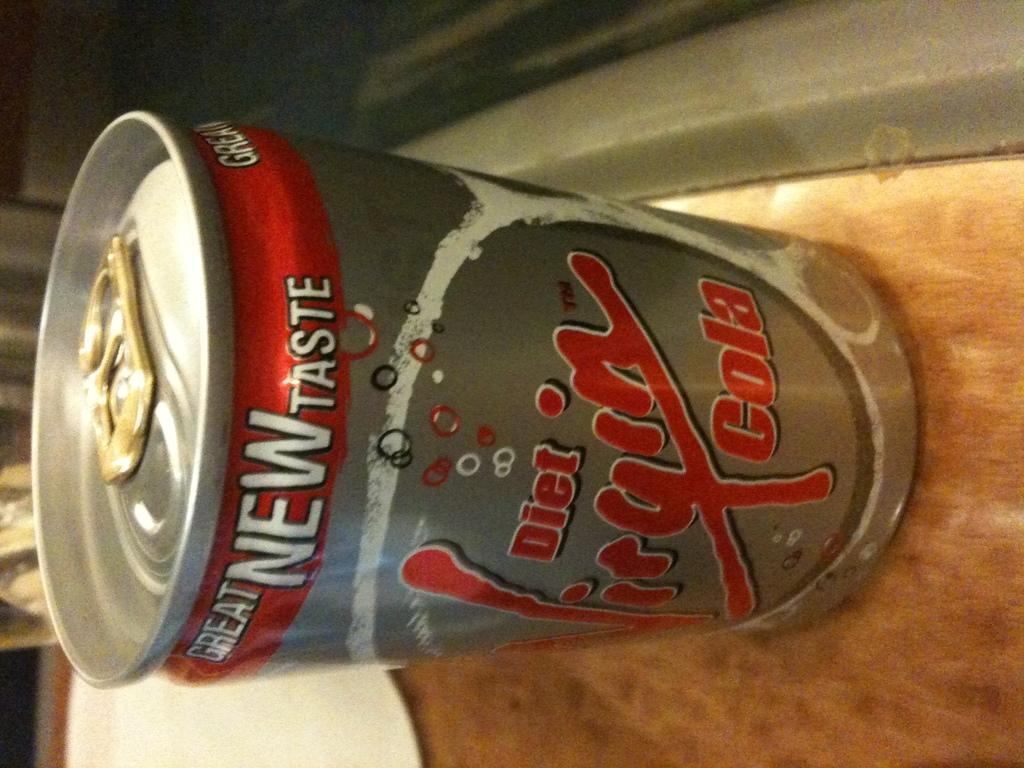<image>
Present a compact description of the photo's key features. Brown surface containing diet cola in a silver can. 